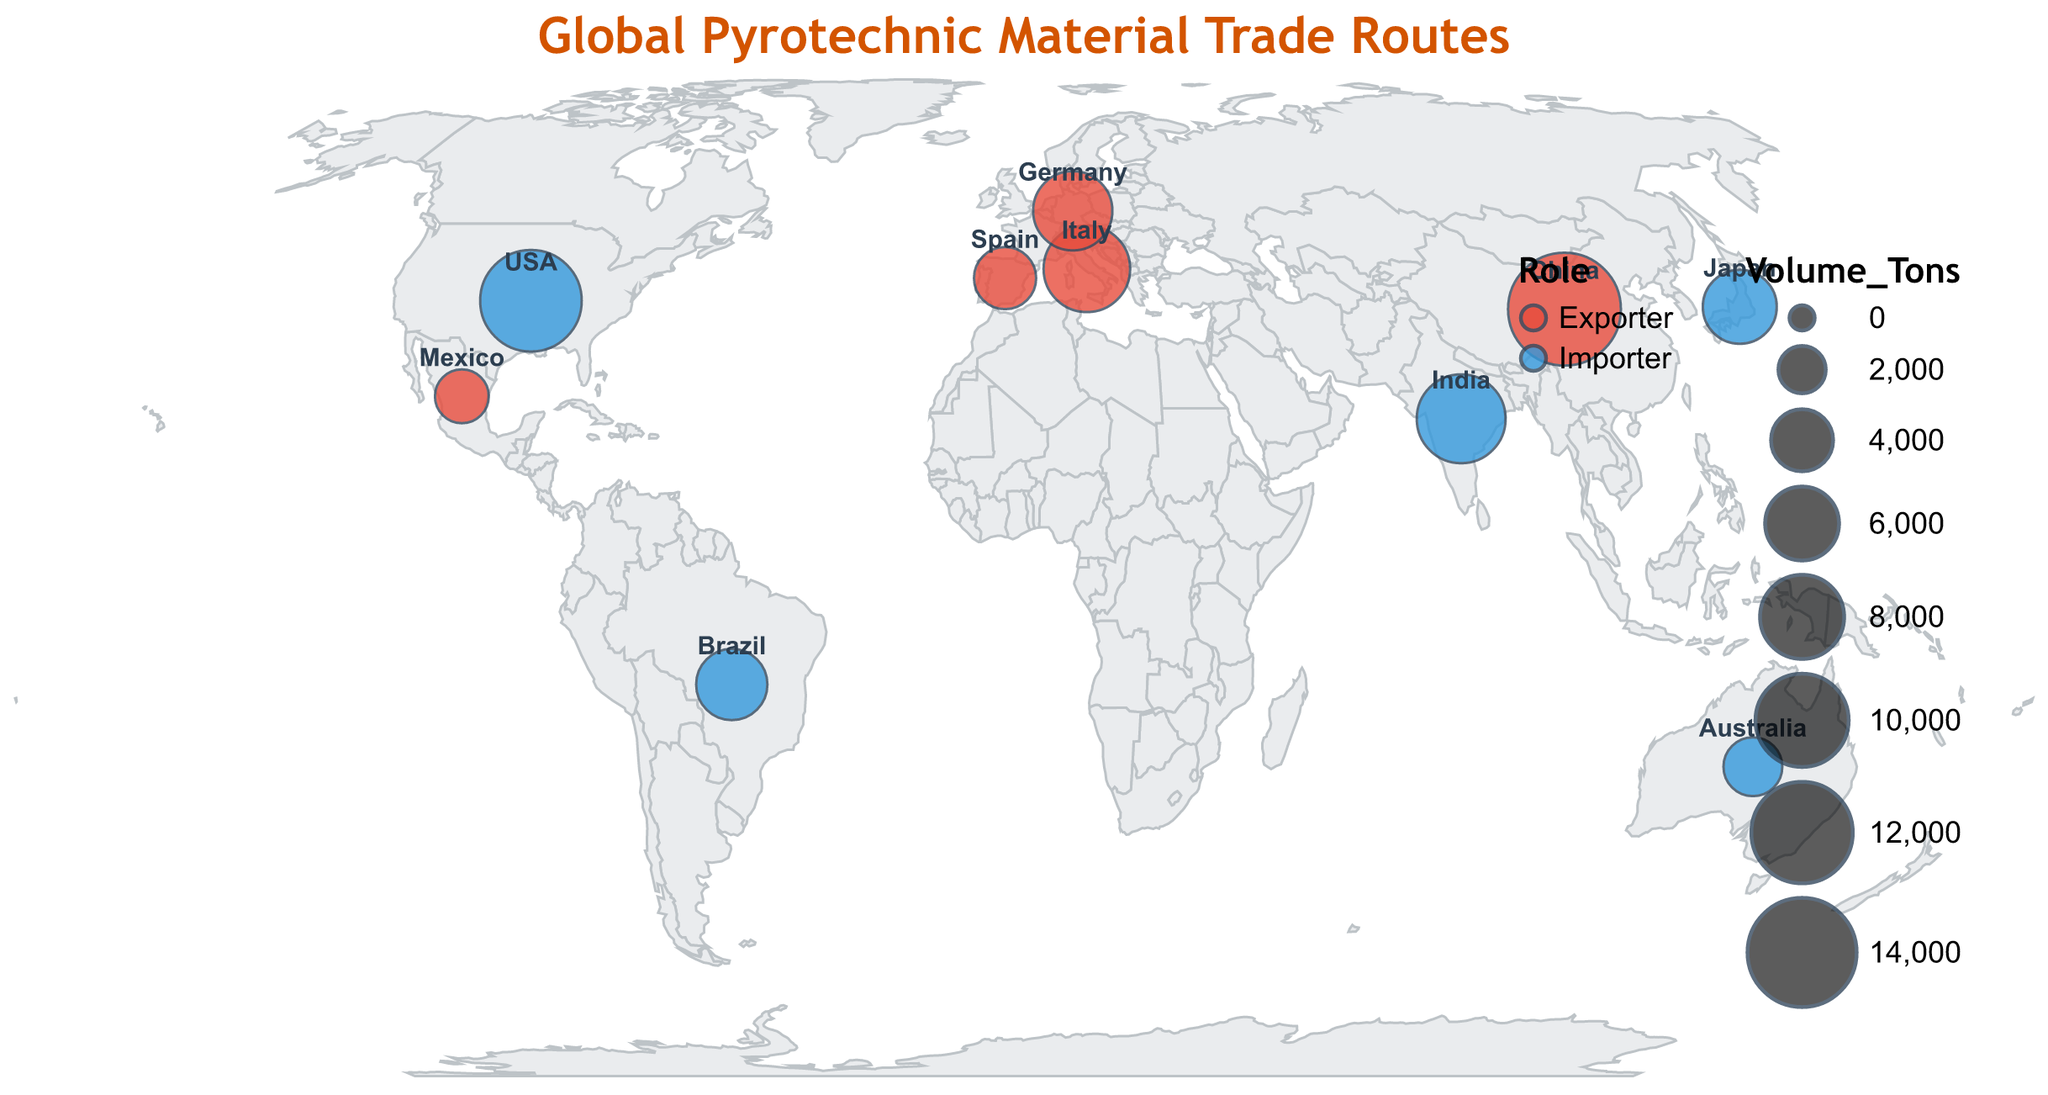How many countries are shown as exporters in the plot? Look for the countries labeled as exporters on the map. They are highlighted with circles and labeled accordingly.
Answer: 5 Which exporter is dealing with the highest volume of pyrotechnic materials? Compare the volume tonnage of all exporters displayed on the map. Sort them visually based on the size of the circles. China has the largest circle indicating the highest volume.
Answer: China What is the primary material imported by India? Identify India on the map, hover over or refer to the tooltip that appears which lists the primary material for India.
Answer: Copper Compounds Which country has the smallest volume of export, and what is their primary material? Find the exporter countries and compare the sizes of their circles. The smallest circle among exporters corresponds to Mexico. Refer to the tooltip to see Mexico's primary material.
Answer: Mexico, Sulfur How does the export volume of Germany compare to that of Spain? Locate Germany and Spain on the map and look at their respective circle sizes. Germany has a larger circle compared to Spain, indicating a higher export volume.
Answer: Germany has a higher volume What are the two major importers of the most diverse (Various Compounds and Multiple) materials? Identify the importers on the map and read the tooltips to see which countries import various compounds. The USA is one of them. The next step is to find which other importer has a different (multiple) material than the typical single ones.
Answer: USA and Australia What is the total volume of pyrotechnic materials imported by Brazil and Japan? Check the volume of pyrotechnic materials imported by Brazil and Japan from the map, then add their volumes together (5500 + 6000).
Answer: 11500 tons Does the USA import more than double the volume that Australia does? Compare the volume imported by the USA (12000 tons) with that of Australia (3500 tons). Calculate if 12000 is more than double of 3500.
Answer: Yes Which continent has the highest number of countries participating in the trade of pyrotechnic materials? Look at the map and count the number of participating countries in each continent. Asia, with China, India, and Japan, has the highest number of participating countries.
Answer: Asia 